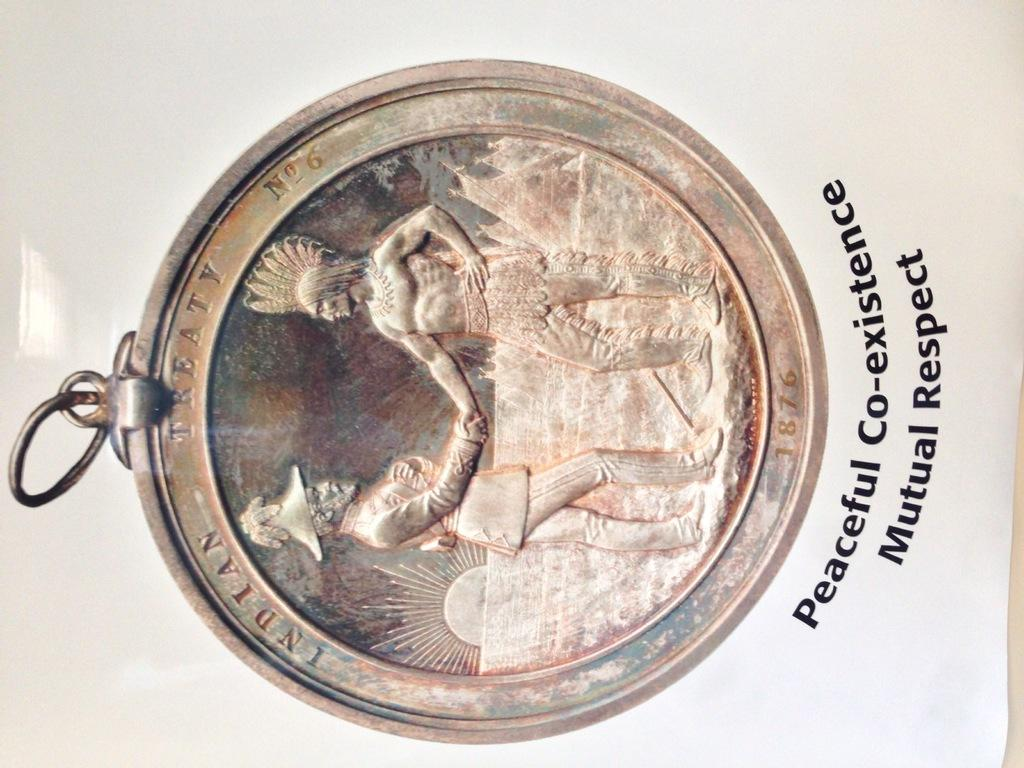<image>
Write a terse but informative summary of the picture. the word treaty is at the top of a coin 